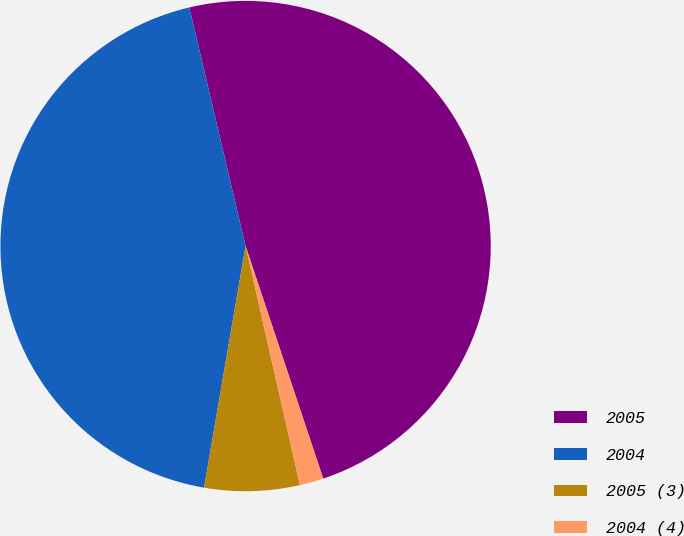Convert chart to OTSL. <chart><loc_0><loc_0><loc_500><loc_500><pie_chart><fcel>2005<fcel>2004<fcel>2005 (3)<fcel>2004 (4)<nl><fcel>48.56%<fcel>43.61%<fcel>6.27%<fcel>1.57%<nl></chart> 